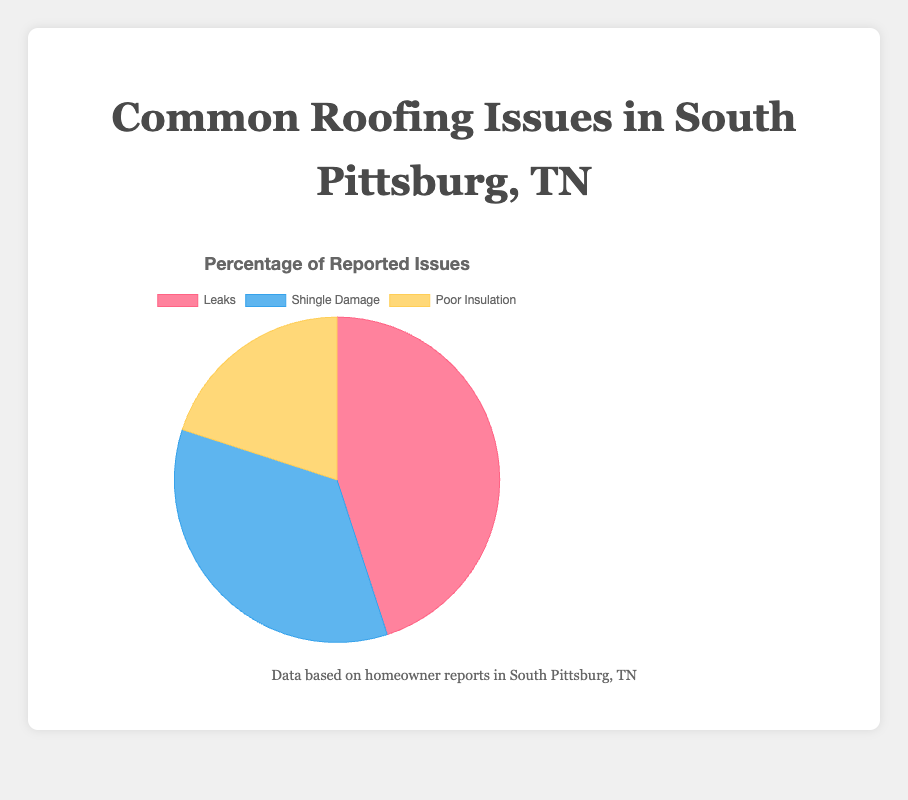What is the most common roofing issue reported by homeowners in South Pittsburg, TN? The chart visually indicates that "Leaks" has the largest portion of the pie chart, suggesting it is the most common issue.
Answer: Leaks What percentage of reported roofing issues does Shingle Damage represent? The chart shows the distribution of issues, and Shingle Damage forms a significant portion of the chart. To find the exact percentage, refer directly to the chart legend.
Answer: 35% Which roofing issue is the least reported by homeowners? By comparing the sizes of the sections in the pie chart, "Poor Insulation" is clearly the smallest segment.
Answer: Poor Insulation How much more common are Leaks than Poor Insulation? Leaks are reported at 45%, while Poor Insulation is reported at 20%. The difference can be calculated by subtracting the smaller percentage from the larger one: 45% - 20% = 25%.
Answer: 25% Is Shingle Damage reported more frequently than Poor Insulation? Comparing the sizes of the pie chart segments, Shingle Damage (35%) is indeed reported more frequently than Poor Insulation (20%).
Answer: Yes Which two issues combined make up more than half of the reported roofing problems? Adding the percentages of each issue: Leaks (45%) + Shingle Damage (35%) = 80%. This sum is greater than 50%, indicating that these two issues combined make up more than half.
Answer: Leaks and Shingle Damage What is the second most common roofing issue reported? Identifying the largest and the second largest segments visually, the second largest part of the pie chart represents Shingle Damage.
Answer: Shingle Damage How many times more common are Leaks compared to Poor Insulation? To determine this, divide the percentage of Leaks (45%) by the percentage of Poor Insulation (20%): 45 / 20 = 2.25.
Answer: 2.25 times What is the combined percentage of Leaks and Poor Insulation? Summing the percentages of Leaks (45%) and Poor Insulation (20%) results in 45% + 20% = 65%.
Answer: 65% Which roofing issue has a yellow color in the chart? By referring to the colors used in the pie chart, Poor Insulation is represented in yellow.
Answer: Poor Insulation 